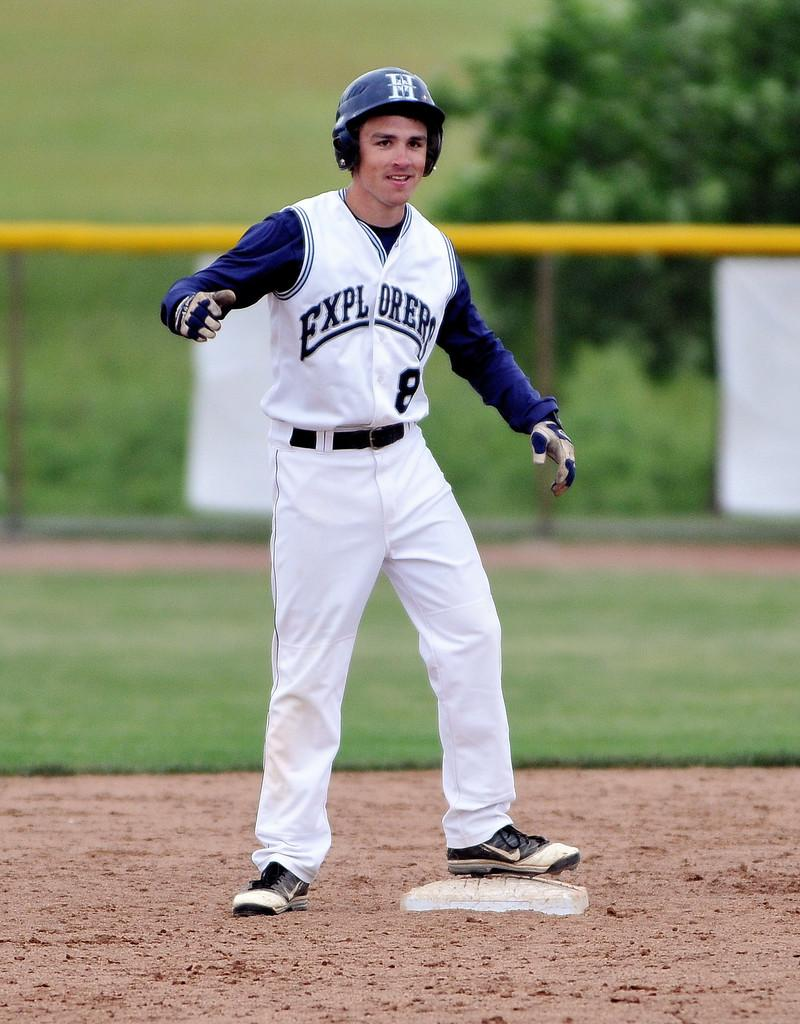<image>
Write a terse but informative summary of the picture. Explorers teammate number 8 is eager to run to the next base. 